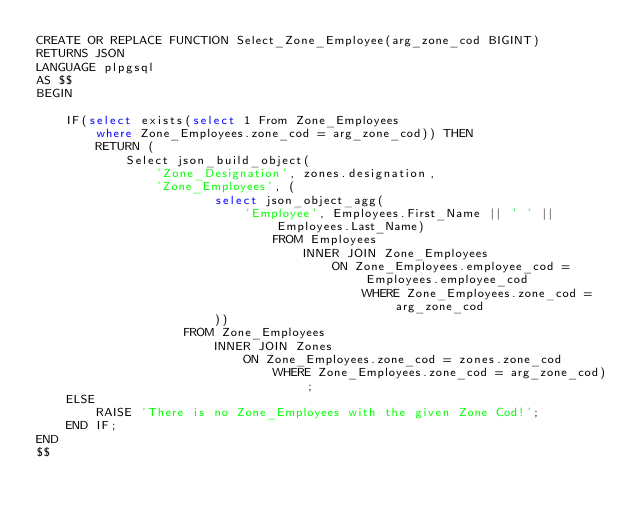Convert code to text. <code><loc_0><loc_0><loc_500><loc_500><_SQL_>CREATE OR REPLACE FUNCTION Select_Zone_Employee(arg_zone_cod BIGINT)
RETURNS JSON
LANGUAGE plpgsql
AS $$
BEGIN
	
	IF(select exists(select 1 From Zone_Employees 
        where Zone_Employees.zone_cod = arg_zone_cod)) THEN
		RETURN (
            Select json_build_object(
			    'Zone_Designation', zones.designation,
                'Zone_Employees', (
                        select json_object_agg(
                            'Employee', Employees.First_Name || ' ' || Employees.Last_Name)
                                FROM Employees
                                    INNER JOIN Zone_Employees
                                        ON Zone_Employees.employee_cod = Employees.employee_cod
                                            WHERE Zone_Employees.zone_cod = arg_zone_cod
                        ))
                    FROM Zone_Employees 
                        INNER JOIN Zones
                            ON Zone_Employees.zone_cod = zones.zone_cod
                                WHERE Zone_Employees.zone_cod = arg_zone_cod);
	ELSE
		RAISE 'There is no Zone_Employees with the given Zone Cod!';
	END IF;
END
$$</code> 